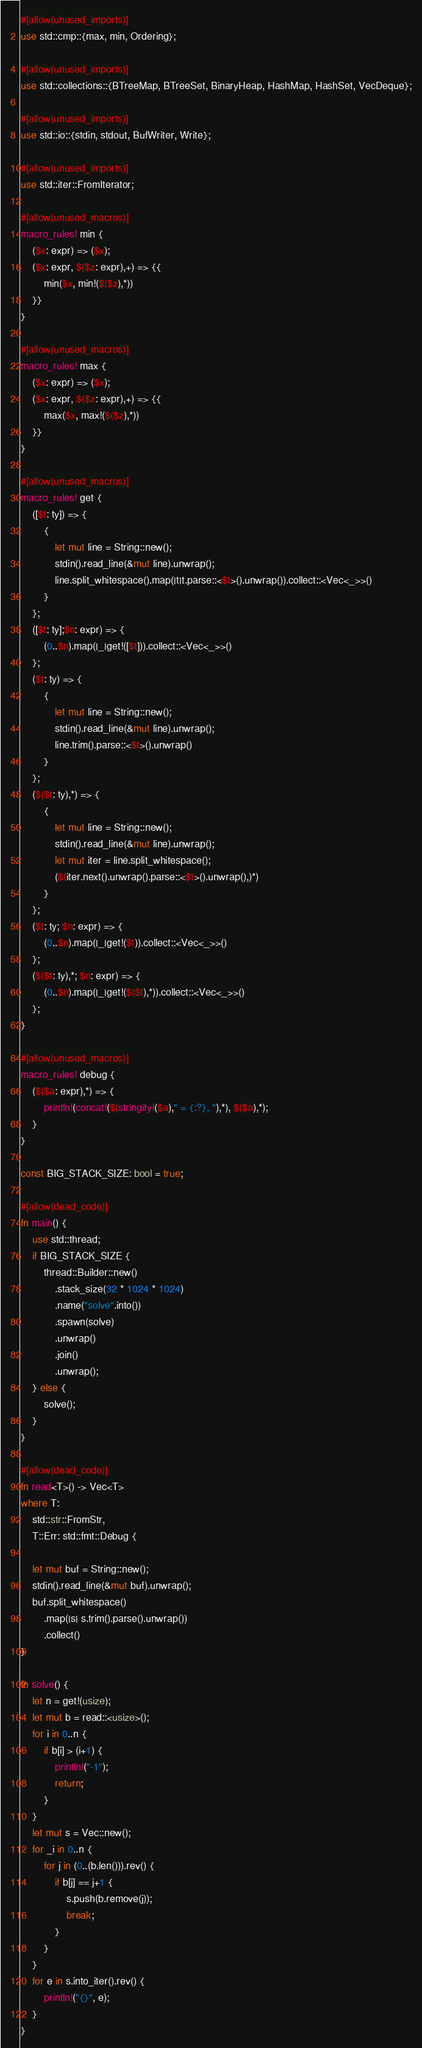Convert code to text. <code><loc_0><loc_0><loc_500><loc_500><_Rust_>#[allow(unused_imports)]
use std::cmp::{max, min, Ordering};

#[allow(unused_imports)]
use std::collections::{BTreeMap, BTreeSet, BinaryHeap, HashMap, HashSet, VecDeque};

#[allow(unused_imports)]
use std::io::{stdin, stdout, BufWriter, Write};

#[allow(unused_imports)]
use std::iter::FromIterator;

#[allow(unused_macros)]
macro_rules! min {
    ($x: expr) => ($x);
    ($x: expr, $($z: expr),+) => {{
        min($x, min!($($z),*))
    }}
}

#[allow(unused_macros)]
macro_rules! max {
    ($x: expr) => ($x);
    ($x: expr, $($z: expr),+) => {{
        max($x, max!($($z),*))
    }}
}

#[allow(unused_macros)]
macro_rules! get { 
    ([$t: ty]) => { 
        { 
            let mut line = String::new(); 
            stdin().read_line(&mut line).unwrap(); 
            line.split_whitespace().map(|t|t.parse::<$t>().unwrap()).collect::<Vec<_>>()
        }
    };
    ([$t: ty];$n: expr) => {
        (0..$n).map(|_|get!([$t])).collect::<Vec<_>>()
    };
    ($t: ty) => {
        {
            let mut line = String::new();
            stdin().read_line(&mut line).unwrap();
            line.trim().parse::<$t>().unwrap()
        }
    };
    ($($t: ty),*) => {
        { 
            let mut line = String::new();
            stdin().read_line(&mut line).unwrap();
            let mut iter = line.split_whitespace();
            ($(iter.next().unwrap().parse::<$t>().unwrap(),)*)
        }
    };
    ($t: ty; $n: expr) => {
        (0..$n).map(|_|get!($t)).collect::<Vec<_>>()
    };
    ($($t: ty),*; $n: expr) => {
        (0..$n).map(|_|get!($($t),*)).collect::<Vec<_>>()
    };
}

#[allow(unused_macros)]
macro_rules! debug { 
    ($($a: expr),*) => { 
        println!(concat!($(stringify!($a)," = {:?}, "),*), $($a),*);
    } 
}

const BIG_STACK_SIZE: bool = true;

#[allow(dead_code)]
fn main() {
    use std::thread;
    if BIG_STACK_SIZE {
        thread::Builder::new()
            .stack_size(32 * 1024 * 1024)
            .name("solve".into())
            .spawn(solve)
            .unwrap()
            .join()
            .unwrap();
    } else {
        solve();
    }
}

#[allow(dead_code)]
fn read<T>() -> Vec<T>
where T:
    std::str::FromStr,
    T::Err: std::fmt::Debug {

    let mut buf = String::new();
    stdin().read_line(&mut buf).unwrap();
    buf.split_whitespace()
        .map(|s| s.trim().parse().unwrap())
        .collect()
}

fn solve() {
    let n = get!(usize);
    let mut b = read::<usize>();
    for i in 0..n {
        if b[i] > (i+1) {
            println!("-1");
            return;
        }
    }
    let mut s = Vec::new();
    for _i in 0..n {
        for j in (0..(b.len())).rev() {
            if b[j] == j+1 {
                s.push(b.remove(j));
                break;
            }
        }
    }
    for e in s.into_iter().rev() {
        println!("{}", e);
    }
}
</code> 